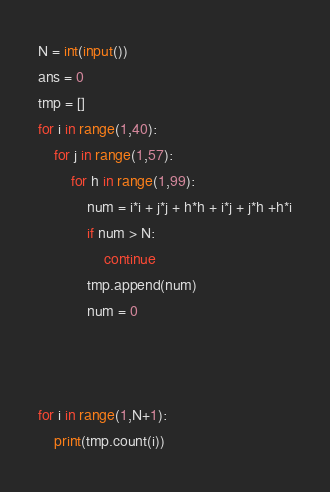Convert code to text. <code><loc_0><loc_0><loc_500><loc_500><_Python_>N = int(input())
ans = 0
tmp = []
for i in range(1,40):
    for j in range(1,57):
        for h in range(1,99):
            num = i*i + j*j + h*h + i*j + j*h +h*i
            if num > N:
                continue
            tmp.append(num)
            num = 0



for i in range(1,N+1):
    print(tmp.count(i))
</code> 